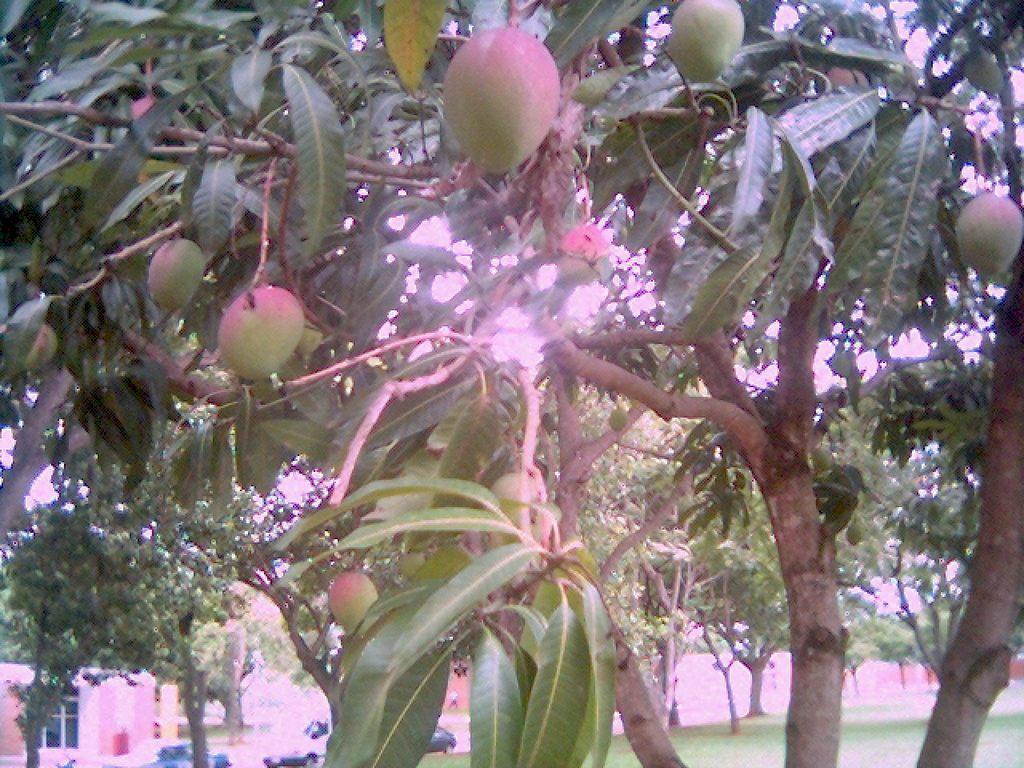Can you describe this image briefly? In this picture we can see some fruits to the trees, behind we can see some houses and trees. 